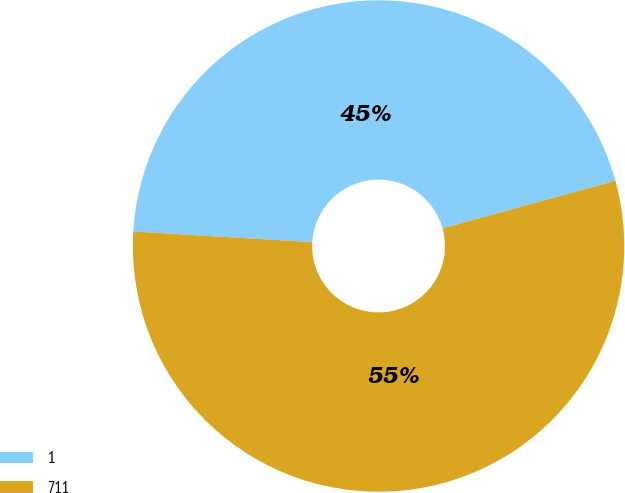Convert chart to OTSL. <chart><loc_0><loc_0><loc_500><loc_500><pie_chart><fcel>1<fcel>711<nl><fcel>44.78%<fcel>55.22%<nl></chart> 